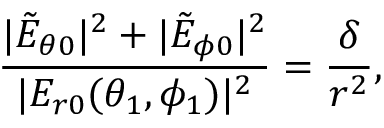<formula> <loc_0><loc_0><loc_500><loc_500>\frac { | \tilde { E } _ { \theta 0 } | ^ { 2 } + | \tilde { E } _ { \phi 0 } | ^ { 2 } } { | E _ { r 0 } ( \theta _ { 1 } , \phi _ { 1 } ) | ^ { 2 } } = \frac { \delta } { r ^ { 2 } } ,</formula> 